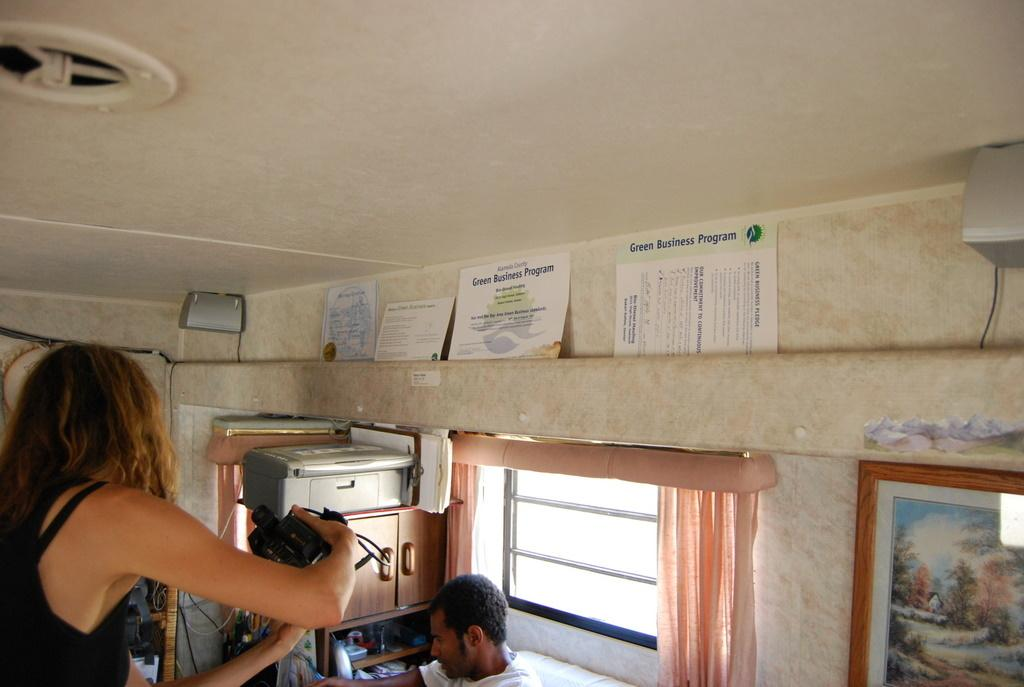<image>
Describe the image concisely. Two people are in a small room with Green Business Program certificate on the wall. 